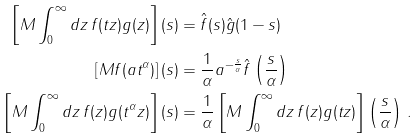Convert formula to latex. <formula><loc_0><loc_0><loc_500><loc_500>\left [ M \int _ { 0 } ^ { \infty } d z \, f ( t z ) g ( z ) \right ] ( s ) & = \hat { f } ( s ) \hat { g } ( 1 - s ) \\ \left [ M f ( a t ^ { \alpha } ) \right ] ( s ) & = \frac { 1 } { \alpha } a ^ { - \frac { s } { \alpha } } \hat { f } \left ( \frac { s } { \alpha } \right ) \\ \left [ M \int _ { 0 } ^ { \infty } d z \, f ( z ) g ( t ^ { \alpha } z ) \right ] ( s ) & = \frac { 1 } { \alpha } \left [ M \int _ { 0 } ^ { \infty } d z \, f ( z ) g ( t z ) \right ] \left ( \frac { s } { \alpha } \right ) \, .</formula> 